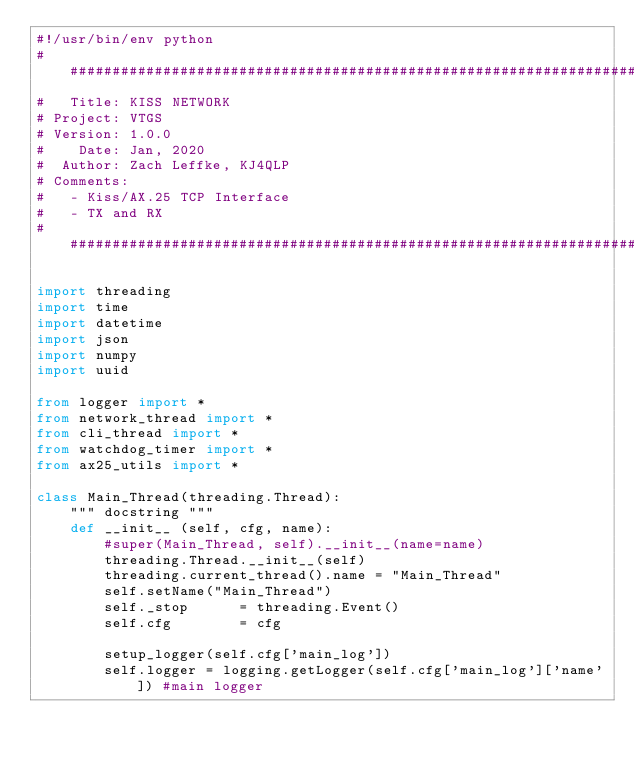<code> <loc_0><loc_0><loc_500><loc_500><_Python_>#!/usr/bin/env python
################################################################################
#   Title: KISS NETWORK
# Project: VTGS
# Version: 1.0.0
#    Date: Jan, 2020
#  Author: Zach Leffke, KJ4QLP
# Comments:
#   - Kiss/AX.25 TCP Interface
#   - TX and RX
################################################################################

import threading
import time
import datetime
import json
import numpy
import uuid

from logger import *
from network_thread import *
from cli_thread import *
from watchdog_timer import *
from ax25_utils import *

class Main_Thread(threading.Thread):
    """ docstring """
    def __init__ (self, cfg, name):
        #super(Main_Thread, self).__init__(name=name)
        threading.Thread.__init__(self)
        threading.current_thread().name = "Main_Thread"
        self.setName("Main_Thread")
        self._stop      = threading.Event()
        self.cfg        = cfg

        setup_logger(self.cfg['main_log'])
        self.logger = logging.getLogger(self.cfg['main_log']['name']) #main logger</code> 